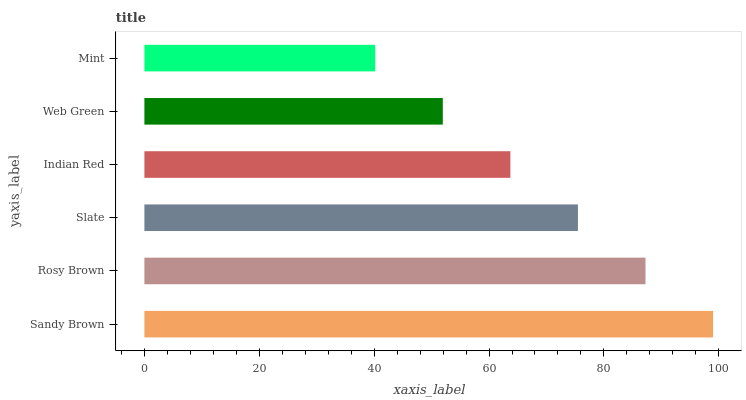Is Mint the minimum?
Answer yes or no. Yes. Is Sandy Brown the maximum?
Answer yes or no. Yes. Is Rosy Brown the minimum?
Answer yes or no. No. Is Rosy Brown the maximum?
Answer yes or no. No. Is Sandy Brown greater than Rosy Brown?
Answer yes or no. Yes. Is Rosy Brown less than Sandy Brown?
Answer yes or no. Yes. Is Rosy Brown greater than Sandy Brown?
Answer yes or no. No. Is Sandy Brown less than Rosy Brown?
Answer yes or no. No. Is Slate the high median?
Answer yes or no. Yes. Is Indian Red the low median?
Answer yes or no. Yes. Is Web Green the high median?
Answer yes or no. No. Is Sandy Brown the low median?
Answer yes or no. No. 